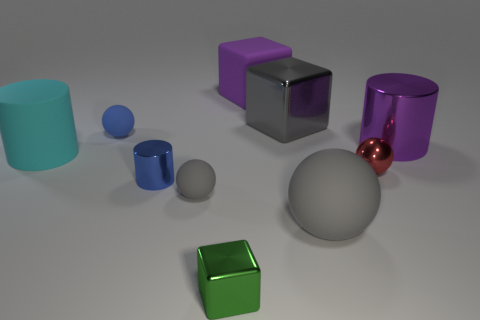Can you tell me the color of the smallest object in the image? The smallest object in the image is blue. 